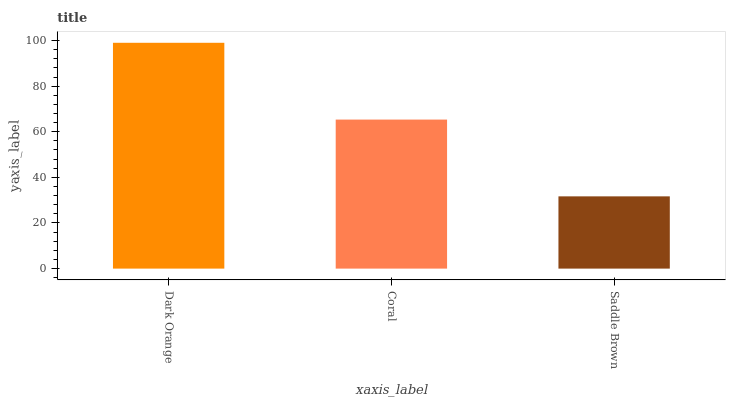Is Saddle Brown the minimum?
Answer yes or no. Yes. Is Dark Orange the maximum?
Answer yes or no. Yes. Is Coral the minimum?
Answer yes or no. No. Is Coral the maximum?
Answer yes or no. No. Is Dark Orange greater than Coral?
Answer yes or no. Yes. Is Coral less than Dark Orange?
Answer yes or no. Yes. Is Coral greater than Dark Orange?
Answer yes or no. No. Is Dark Orange less than Coral?
Answer yes or no. No. Is Coral the high median?
Answer yes or no. Yes. Is Coral the low median?
Answer yes or no. Yes. Is Saddle Brown the high median?
Answer yes or no. No. Is Dark Orange the low median?
Answer yes or no. No. 